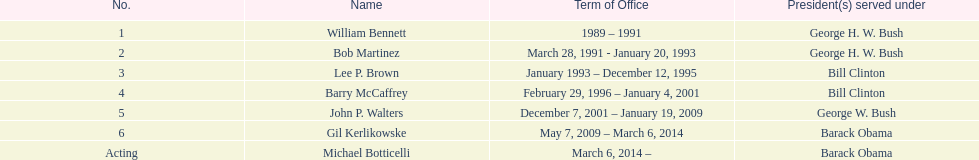Who was the next appointed director after lee p. brown? Barry McCaffrey. 